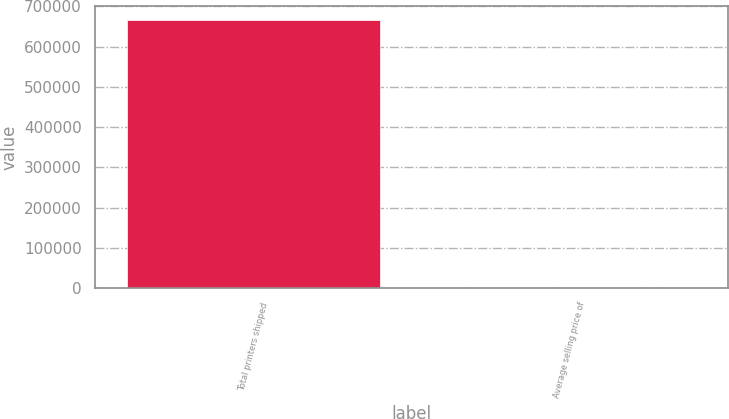Convert chart. <chart><loc_0><loc_0><loc_500><loc_500><bar_chart><fcel>Total printers shipped<fcel>Average selling price of<nl><fcel>667461<fcel>652<nl></chart> 